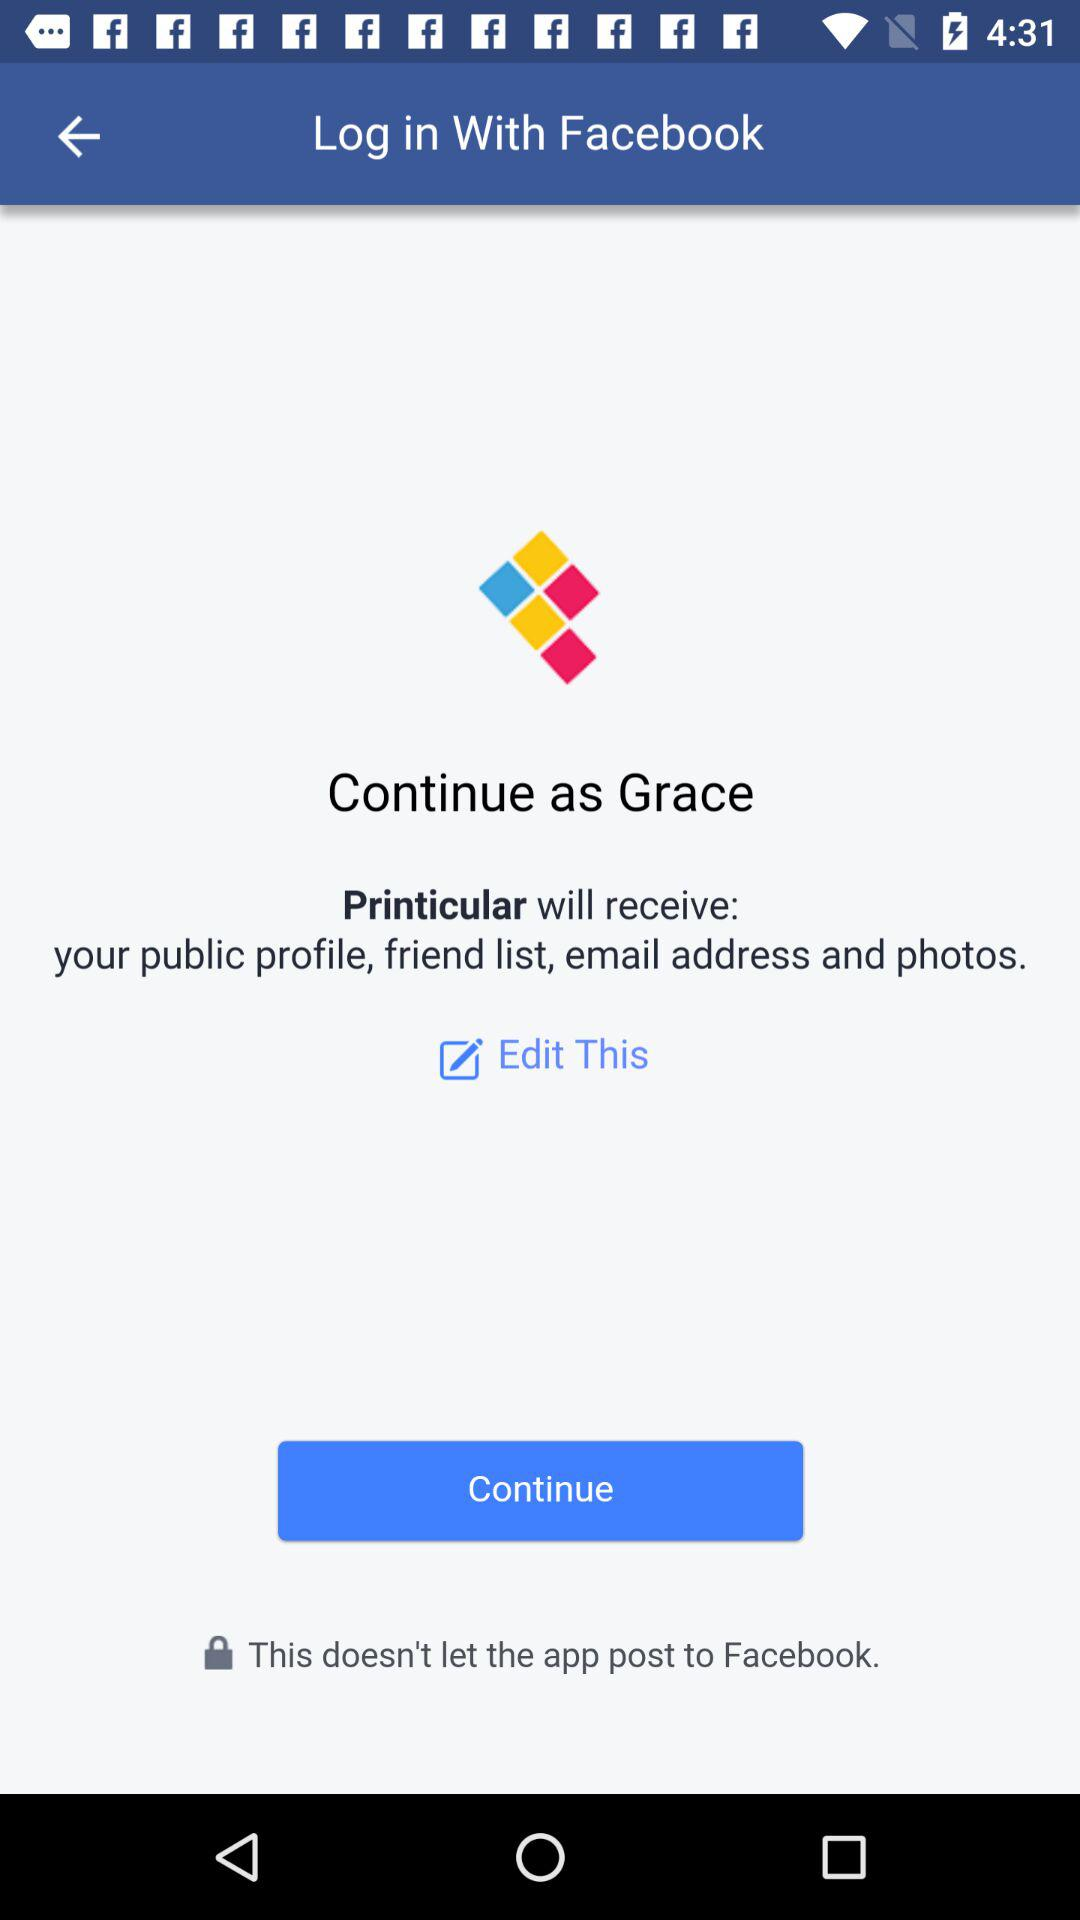Through what account login can be done? Login can be done through "Facebook". 